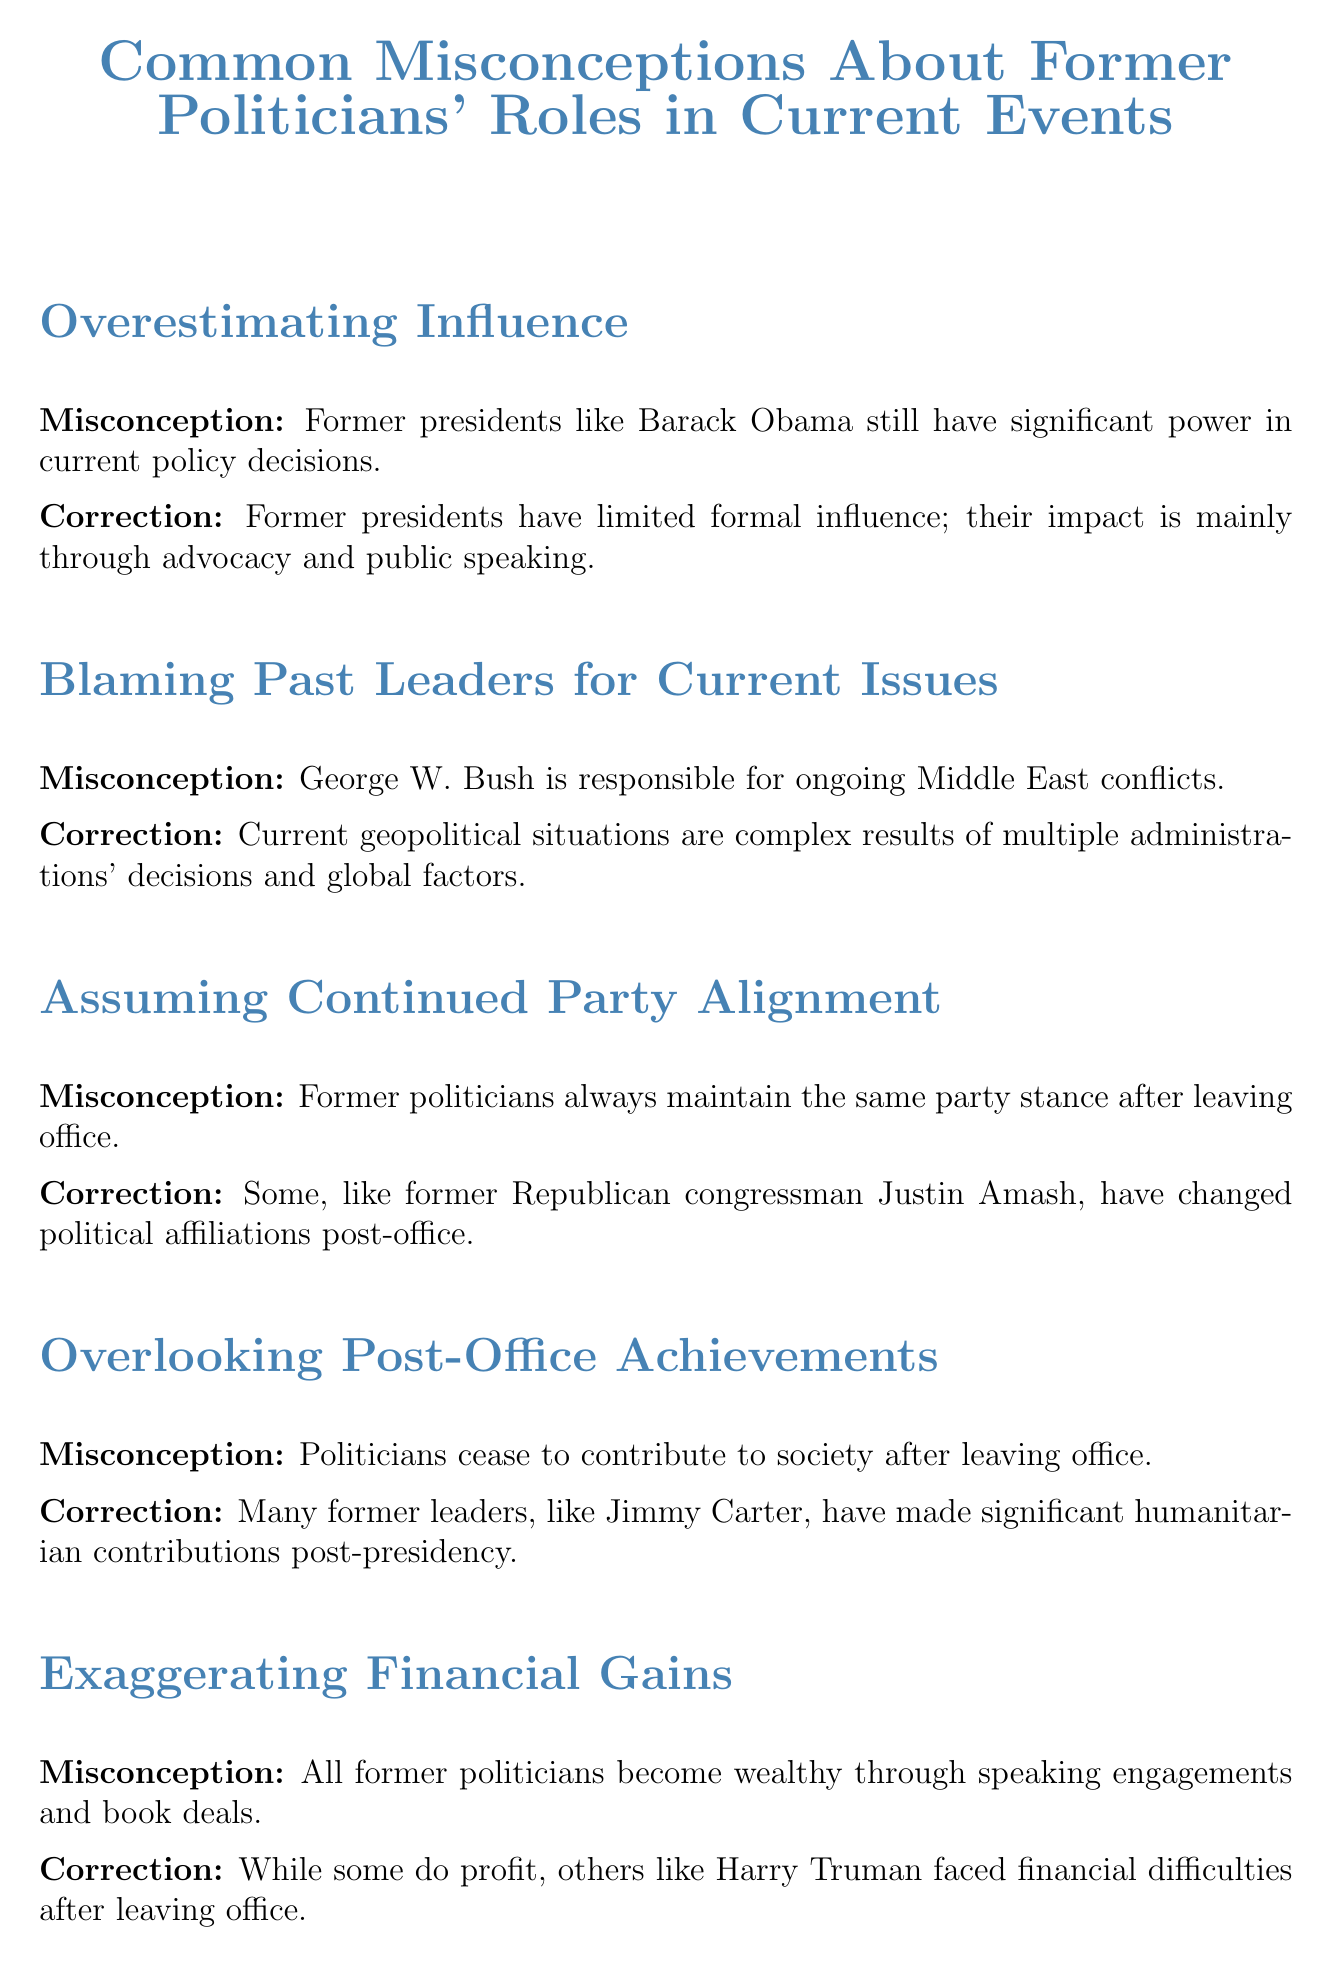What was the first misconception mentioned in the document? The document states that the first misconception is about the influence of former presidents like Barack Obama on current policy decisions.
Answer: Overestimating Influence Who was cited as an example of a former politician who changed political affiliations? The document mentions former Republican congressman Justin Amash as an example of someone who has changed their political affiliations after leaving office.
Answer: Justin Amash What is one of the contributions mentioned for former president Jimmy Carter? The document highlights that many former leaders, including Jimmy Carter, have made significant humanitarian contributions post-presidency.
Answer: Humanitarian contributions Which former president faced financial difficulties after leaving office? The document specifically points out Harry Truman as a former politician who had financial difficulties.
Answer: Harry Truman What should be recognized about former politicians' roles according to the conclusion? The conclusion emphasizes the importance of viewing former politicians' roles and influences objectively, acknowledging both limitations and potential contributions.
Answer: Objectively How many misconceptions are discussed in the document? The document outlines a total of five misconceptions regarding former politicians and their roles in current events.
Answer: Five 